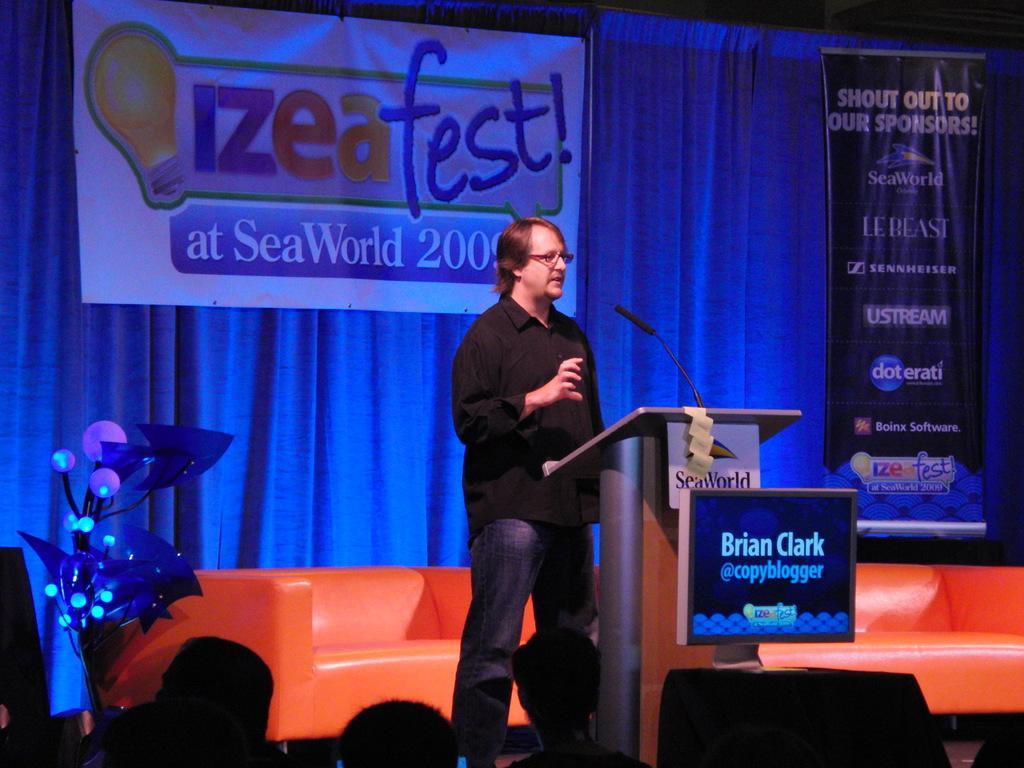Can you describe this image briefly? In this image there is one person standing in middle of this image is wearing black color shirt and there a Mic on right side to him and there is a curtain in the background. there are some persons in bottom of this image. There is a board with some text on the top of this image. 